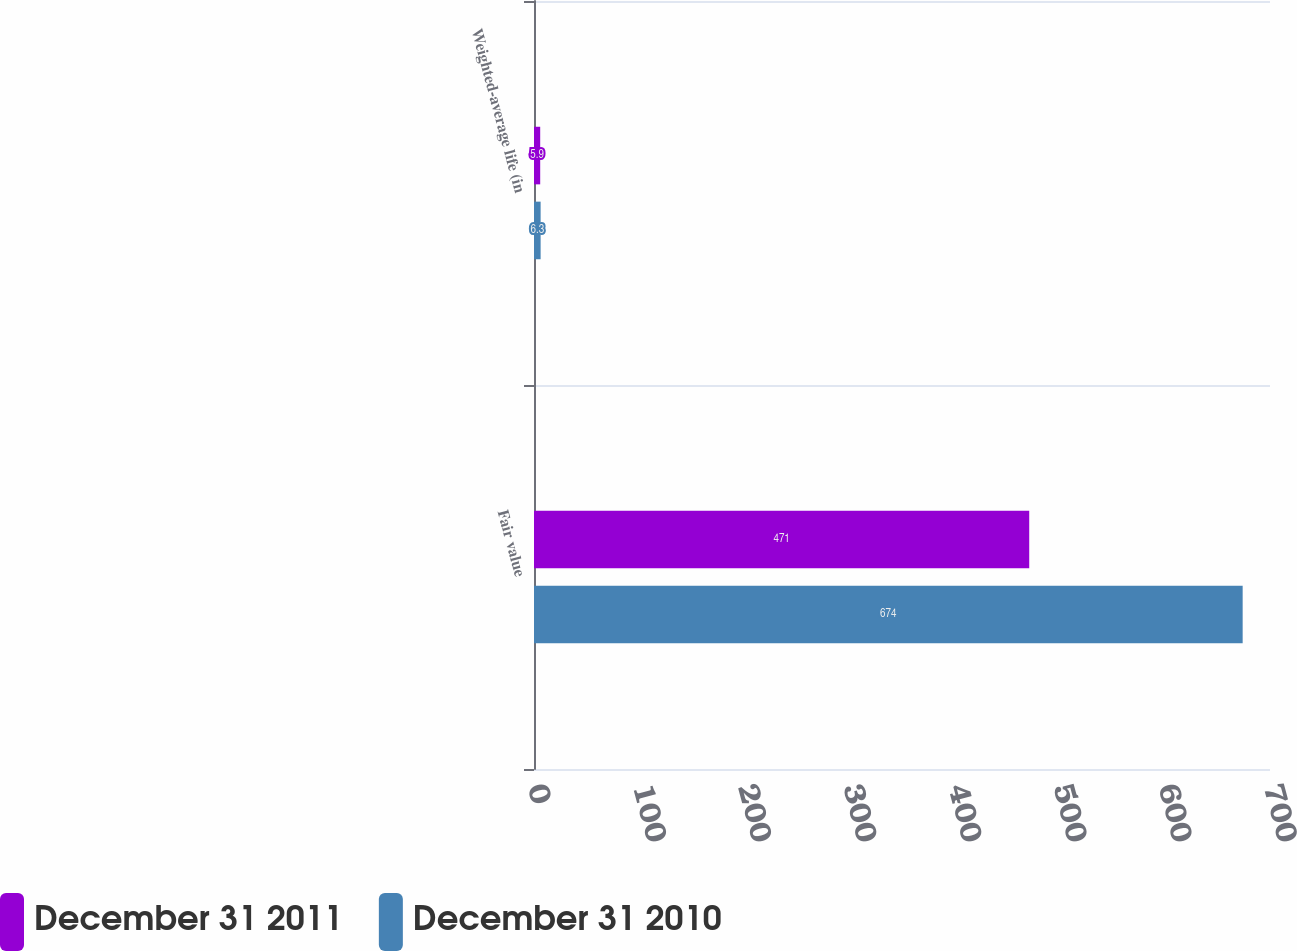Convert chart to OTSL. <chart><loc_0><loc_0><loc_500><loc_500><stacked_bar_chart><ecel><fcel>Fair value<fcel>Weighted-average life (in<nl><fcel>December 31 2011<fcel>471<fcel>5.9<nl><fcel>December 31 2010<fcel>674<fcel>6.3<nl></chart> 